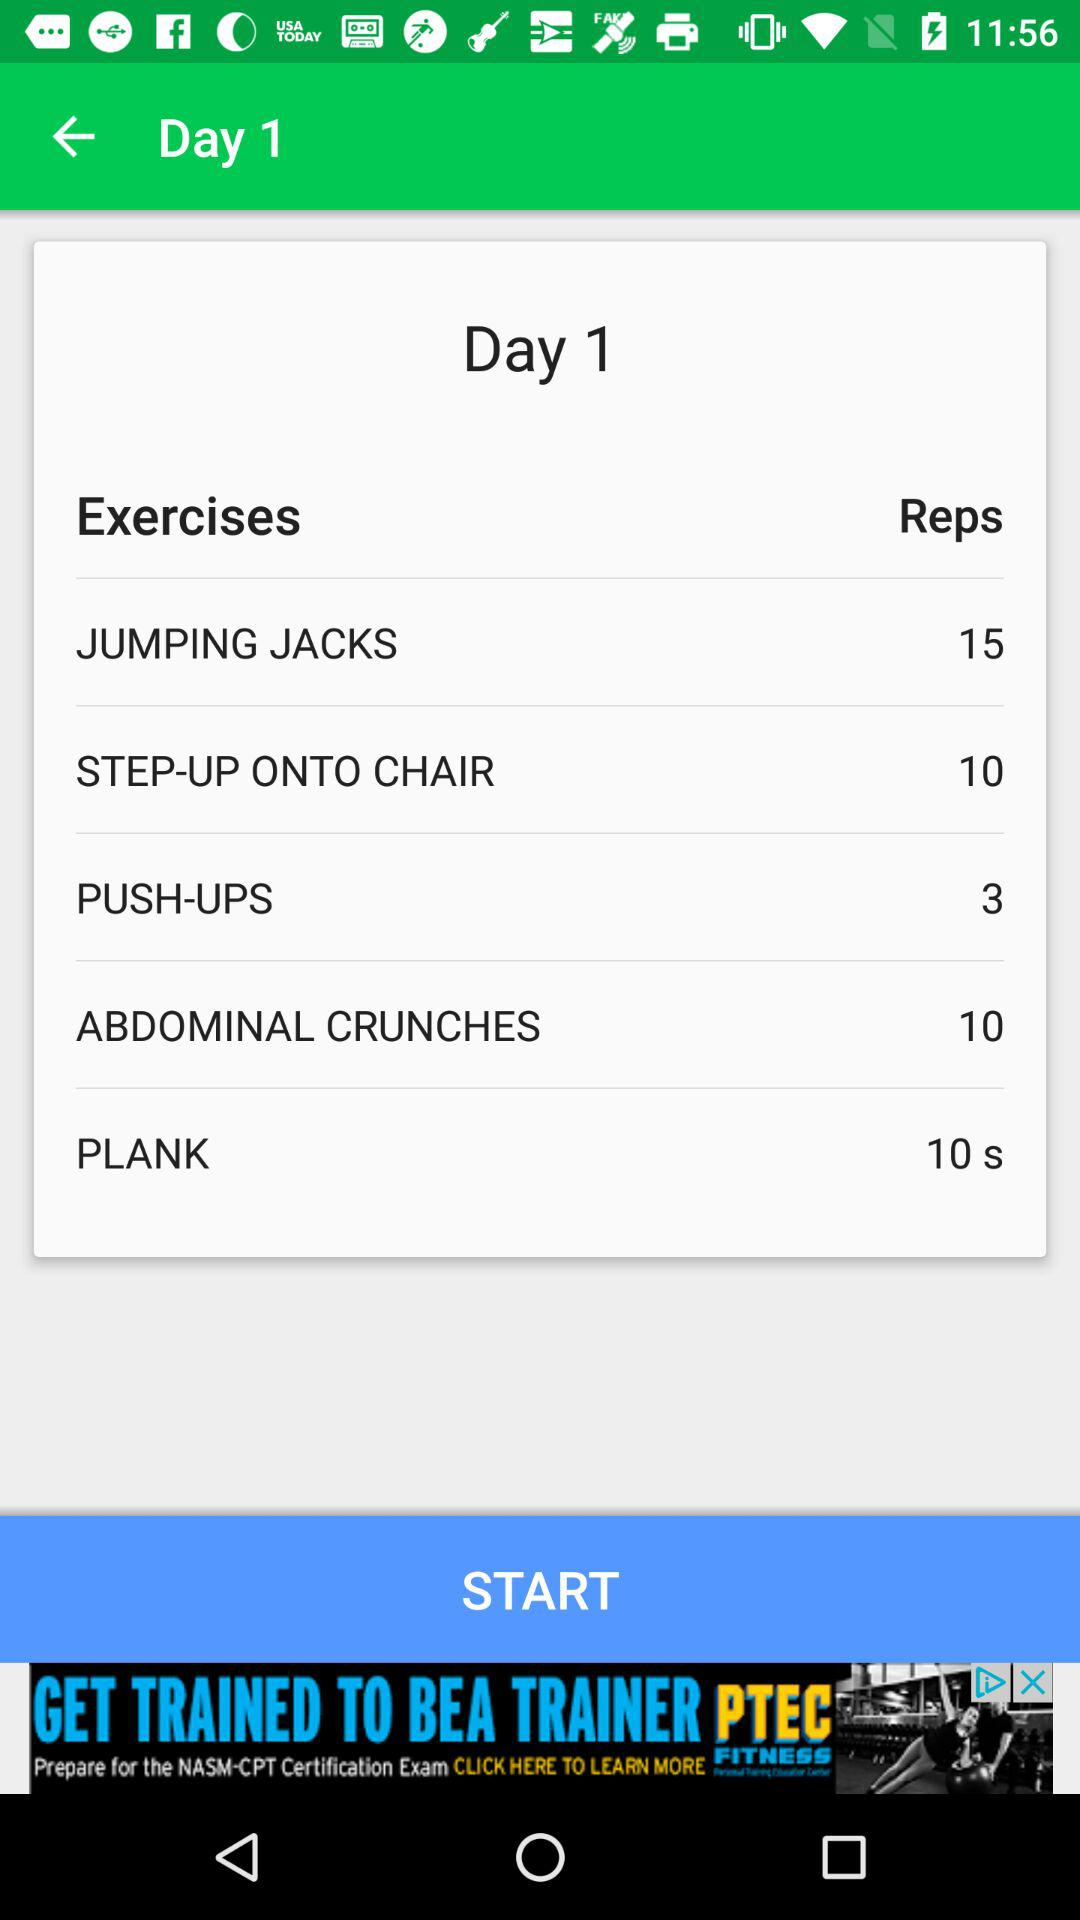How many reps of abdominal crunches are set for day 1? There are 10 reps of abdominal crunches set for day 1. 